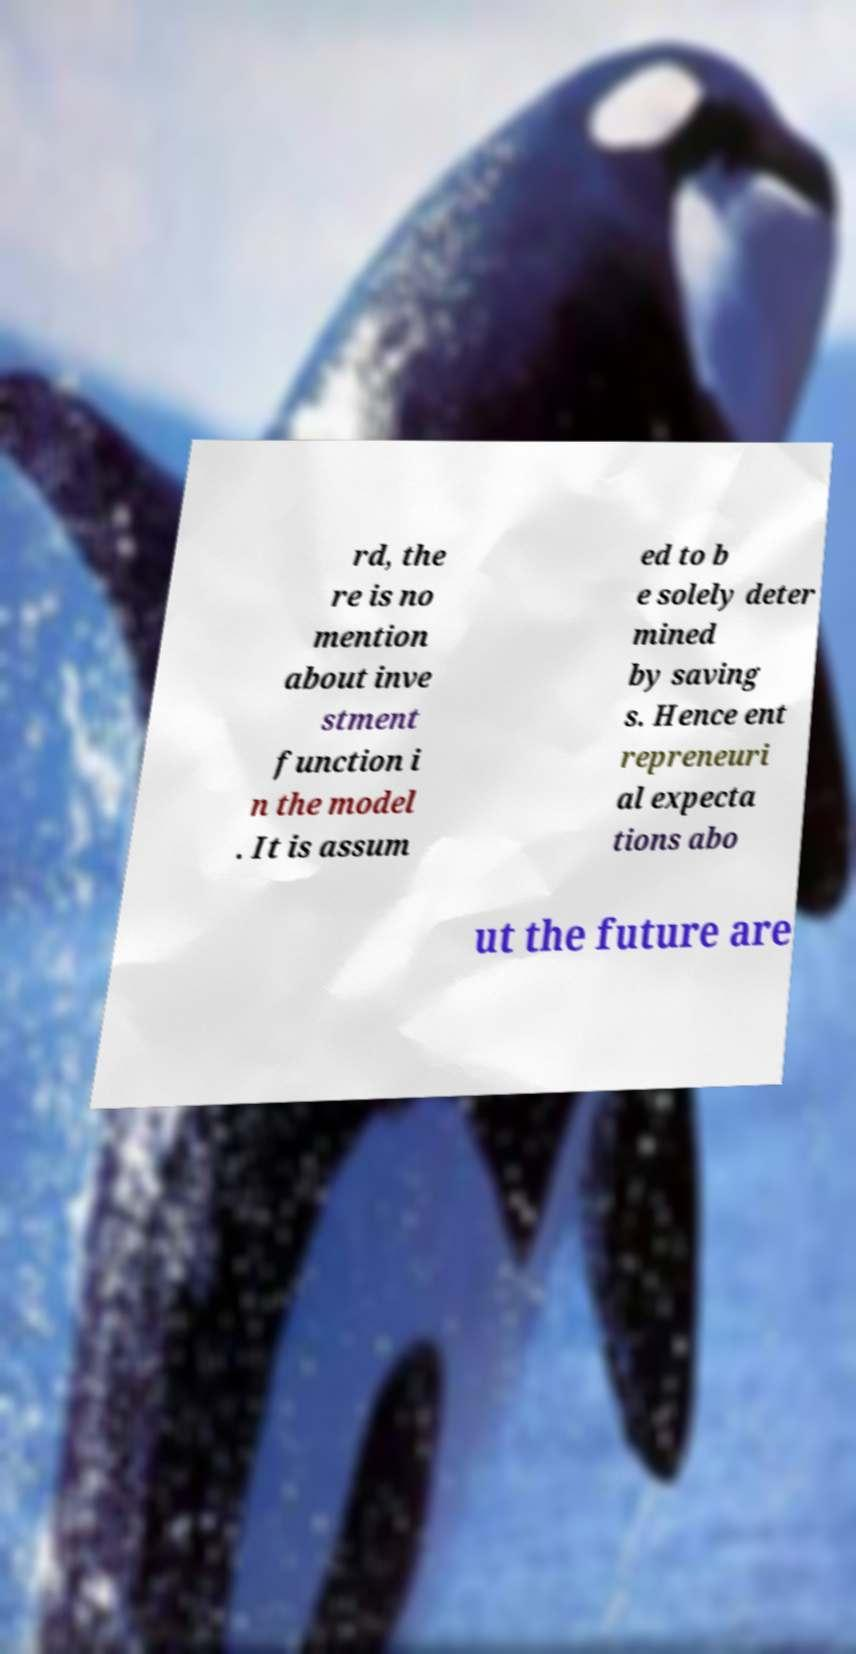Please read and relay the text visible in this image. What does it say? rd, the re is no mention about inve stment function i n the model . It is assum ed to b e solely deter mined by saving s. Hence ent repreneuri al expecta tions abo ut the future are 